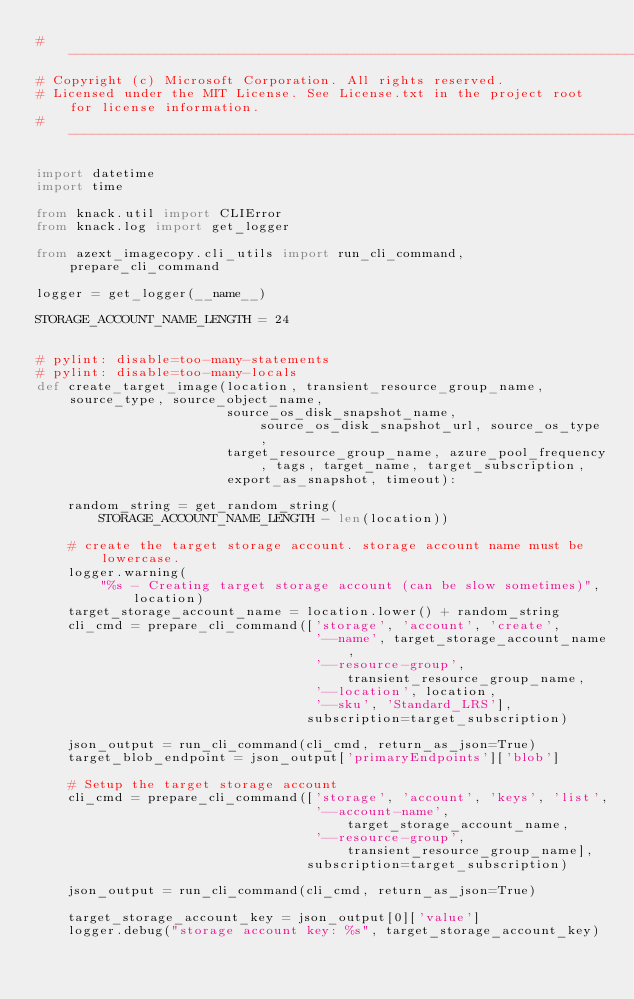<code> <loc_0><loc_0><loc_500><loc_500><_Python_># --------------------------------------------------------------------------------------------
# Copyright (c) Microsoft Corporation. All rights reserved.
# Licensed under the MIT License. See License.txt in the project root for license information.
# --------------------------------------------------------------------------------------------

import datetime
import time

from knack.util import CLIError
from knack.log import get_logger

from azext_imagecopy.cli_utils import run_cli_command, prepare_cli_command

logger = get_logger(__name__)

STORAGE_ACCOUNT_NAME_LENGTH = 24


# pylint: disable=too-many-statements
# pylint: disable=too-many-locals
def create_target_image(location, transient_resource_group_name, source_type, source_object_name,
                        source_os_disk_snapshot_name, source_os_disk_snapshot_url, source_os_type,
                        target_resource_group_name, azure_pool_frequency, tags, target_name, target_subscription,
                        export_as_snapshot, timeout):

    random_string = get_random_string(
        STORAGE_ACCOUNT_NAME_LENGTH - len(location))

    # create the target storage account. storage account name must be lowercase.
    logger.warning(
        "%s - Creating target storage account (can be slow sometimes)", location)
    target_storage_account_name = location.lower() + random_string
    cli_cmd = prepare_cli_command(['storage', 'account', 'create',
                                   '--name', target_storage_account_name,
                                   '--resource-group', transient_resource_group_name,
                                   '--location', location,
                                   '--sku', 'Standard_LRS'],
                                  subscription=target_subscription)

    json_output = run_cli_command(cli_cmd, return_as_json=True)
    target_blob_endpoint = json_output['primaryEndpoints']['blob']

    # Setup the target storage account
    cli_cmd = prepare_cli_command(['storage', 'account', 'keys', 'list',
                                   '--account-name', target_storage_account_name,
                                   '--resource-group', transient_resource_group_name],
                                  subscription=target_subscription)

    json_output = run_cli_command(cli_cmd, return_as_json=True)

    target_storage_account_key = json_output[0]['value']
    logger.debug("storage account key: %s", target_storage_account_key)
</code> 